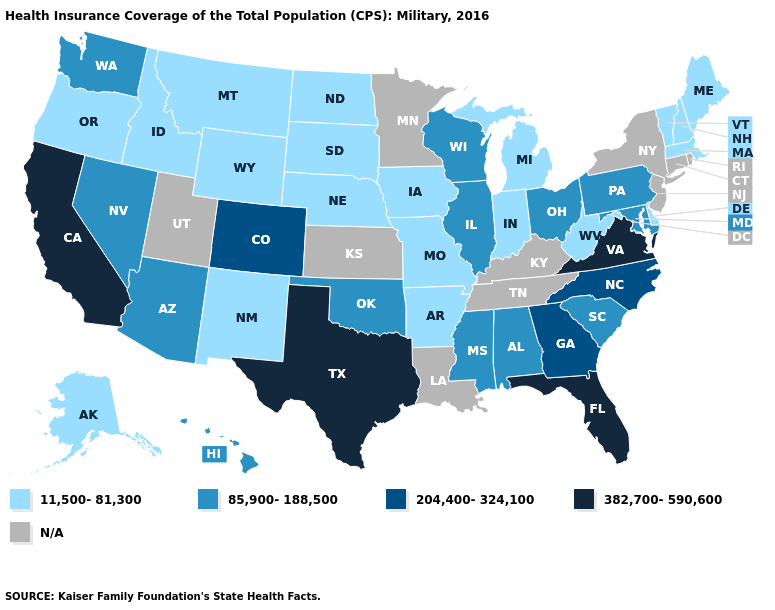What is the lowest value in the USA?
Keep it brief. 11,500-81,300. Name the states that have a value in the range 11,500-81,300?
Quick response, please. Alaska, Arkansas, Delaware, Idaho, Indiana, Iowa, Maine, Massachusetts, Michigan, Missouri, Montana, Nebraska, New Hampshire, New Mexico, North Dakota, Oregon, South Dakota, Vermont, West Virginia, Wyoming. Name the states that have a value in the range 204,400-324,100?
Give a very brief answer. Colorado, Georgia, North Carolina. Name the states that have a value in the range 204,400-324,100?
Short answer required. Colorado, Georgia, North Carolina. What is the lowest value in the USA?
Short answer required. 11,500-81,300. What is the lowest value in the Northeast?
Be succinct. 11,500-81,300. Which states have the highest value in the USA?
Short answer required. California, Florida, Texas, Virginia. What is the highest value in the USA?
Concise answer only. 382,700-590,600. What is the value of Georgia?
Short answer required. 204,400-324,100. Which states have the lowest value in the USA?
Concise answer only. Alaska, Arkansas, Delaware, Idaho, Indiana, Iowa, Maine, Massachusetts, Michigan, Missouri, Montana, Nebraska, New Hampshire, New Mexico, North Dakota, Oregon, South Dakota, Vermont, West Virginia, Wyoming. Among the states that border Wisconsin , does Illinois have the highest value?
Concise answer only. Yes. What is the value of North Carolina?
Answer briefly. 204,400-324,100. 